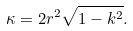Convert formula to latex. <formula><loc_0><loc_0><loc_500><loc_500>\kappa = 2 r ^ { 2 } \sqrt { 1 - k ^ { 2 } } .</formula> 